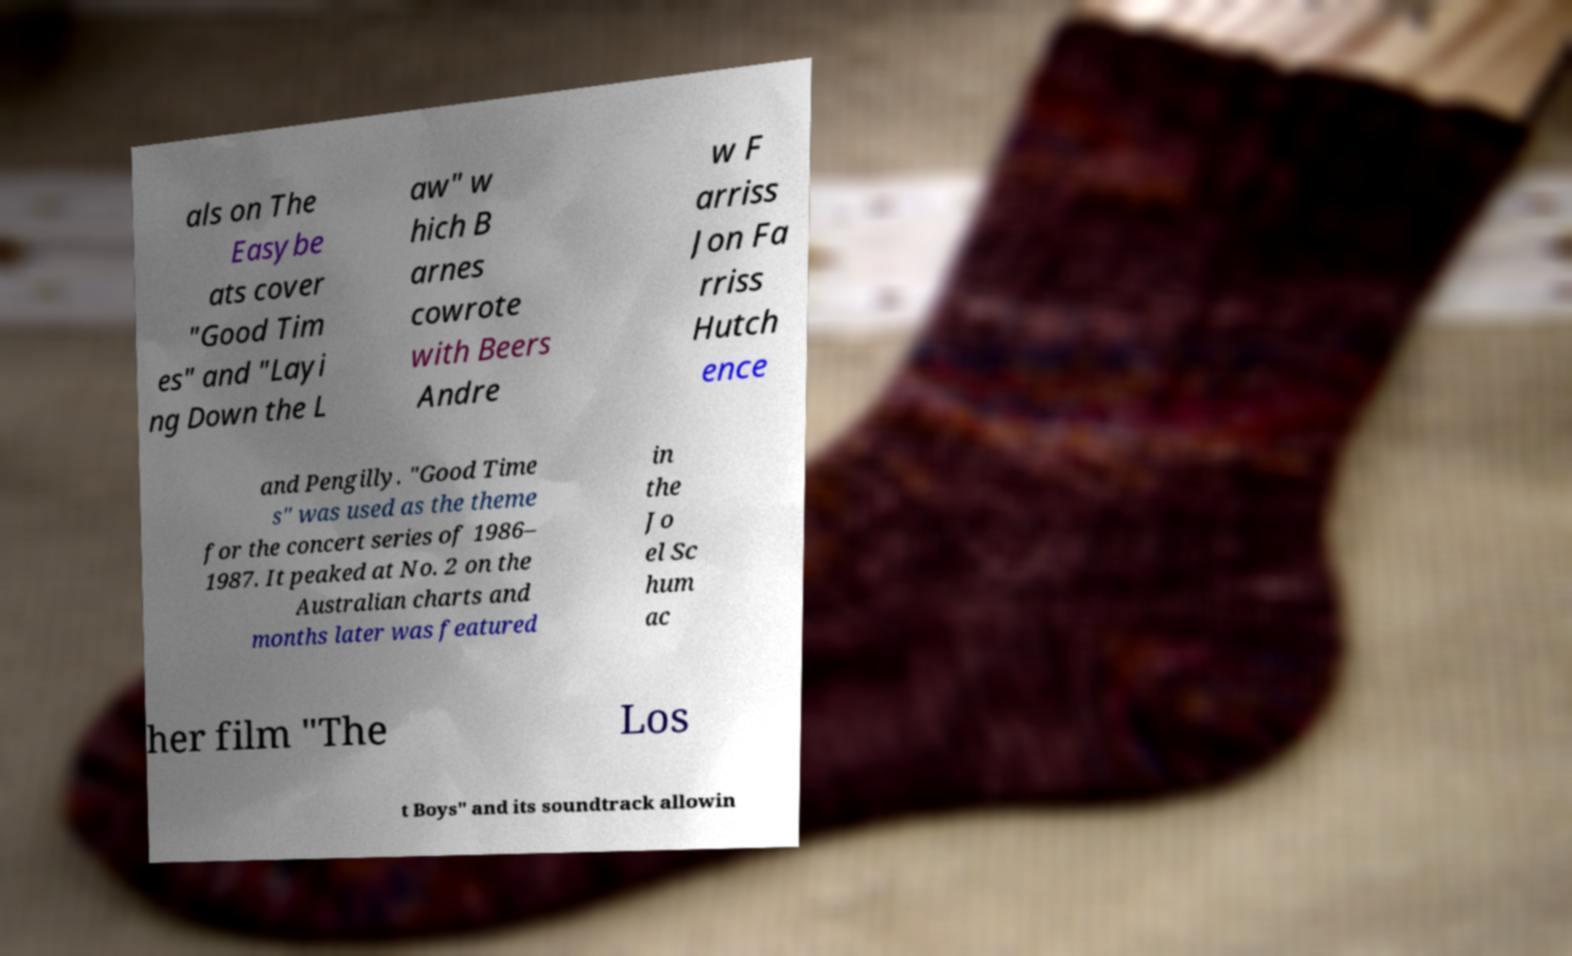For documentation purposes, I need the text within this image transcribed. Could you provide that? als on The Easybe ats cover "Good Tim es" and "Layi ng Down the L aw" w hich B arnes cowrote with Beers Andre w F arriss Jon Fa rriss Hutch ence and Pengilly. "Good Time s" was used as the theme for the concert series of 1986– 1987. It peaked at No. 2 on the Australian charts and months later was featured in the Jo el Sc hum ac her film "The Los t Boys" and its soundtrack allowin 